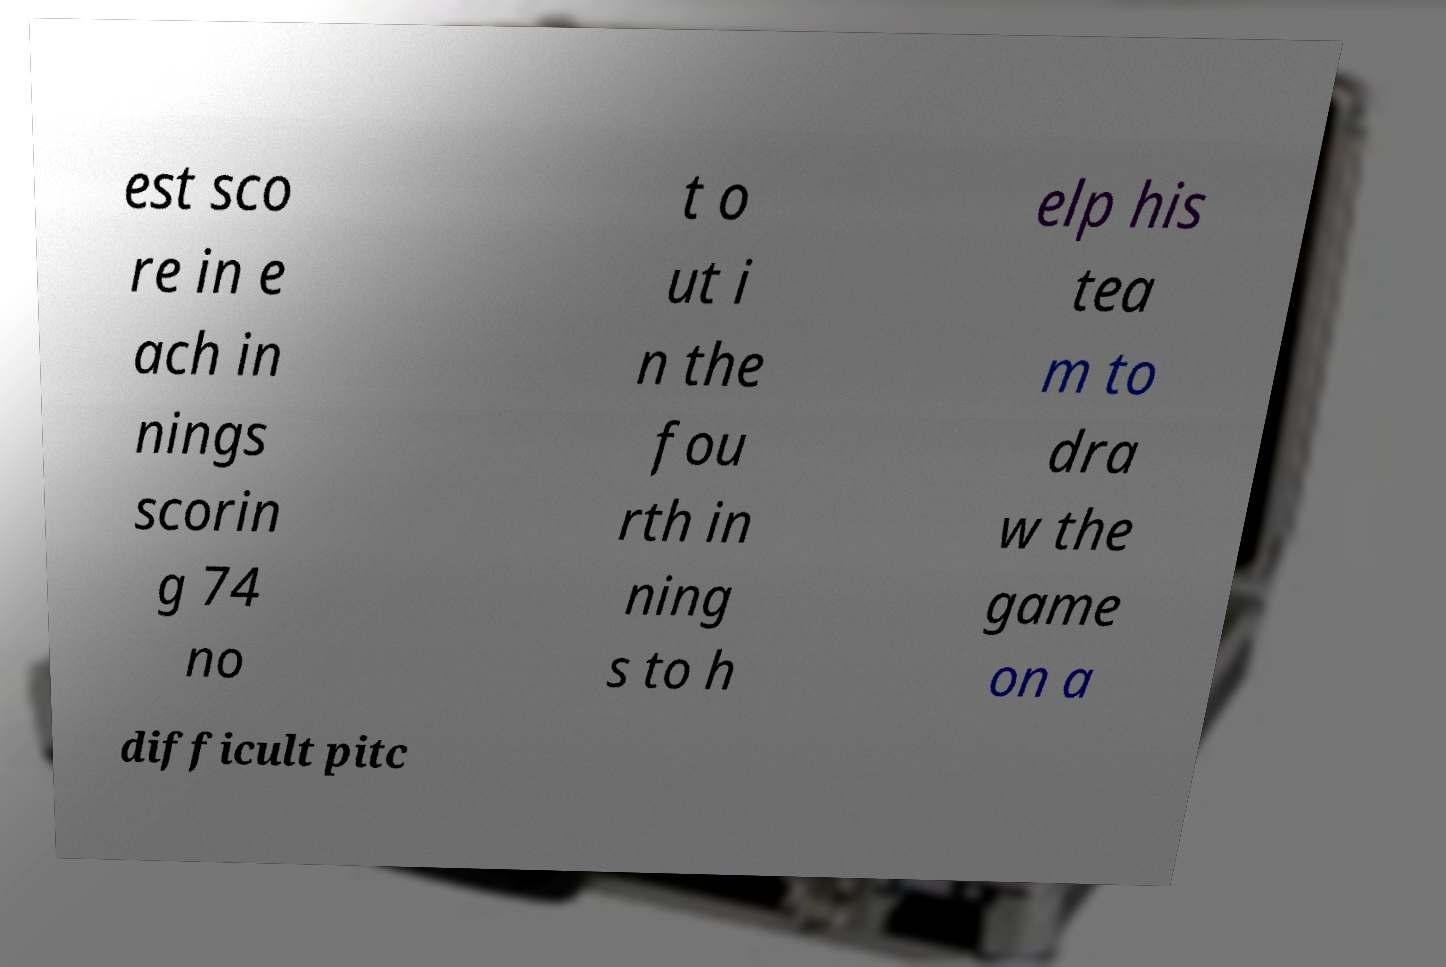There's text embedded in this image that I need extracted. Can you transcribe it verbatim? est sco re in e ach in nings scorin g 74 no t o ut i n the fou rth in ning s to h elp his tea m to dra w the game on a difficult pitc 